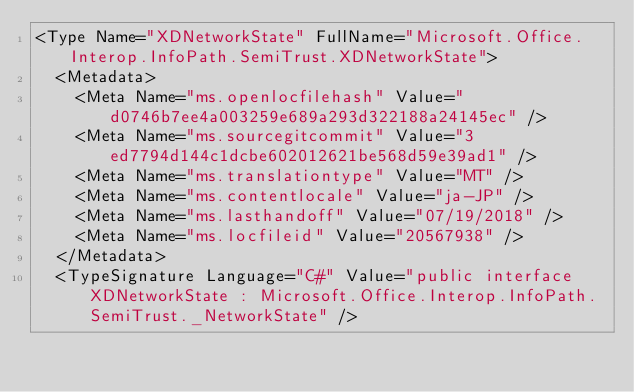<code> <loc_0><loc_0><loc_500><loc_500><_XML_><Type Name="XDNetworkState" FullName="Microsoft.Office.Interop.InfoPath.SemiTrust.XDNetworkState">
  <Metadata>
    <Meta Name="ms.openlocfilehash" Value="d0746b7ee4a003259e689a293d322188a24145ec" />
    <Meta Name="ms.sourcegitcommit" Value="3ed7794d144c1dcbe602012621be568d59e39ad1" />
    <Meta Name="ms.translationtype" Value="MT" />
    <Meta Name="ms.contentlocale" Value="ja-JP" />
    <Meta Name="ms.lasthandoff" Value="07/19/2018" />
    <Meta Name="ms.locfileid" Value="20567938" />
  </Metadata>
  <TypeSignature Language="C#" Value="public interface XDNetworkState : Microsoft.Office.Interop.InfoPath.SemiTrust._NetworkState" /></code> 